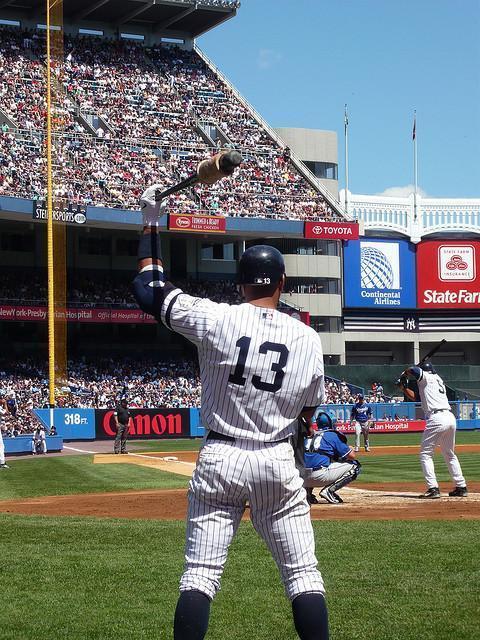How many people are visible?
Give a very brief answer. 4. How many teddy bears are wearing a hair bow?
Give a very brief answer. 0. 